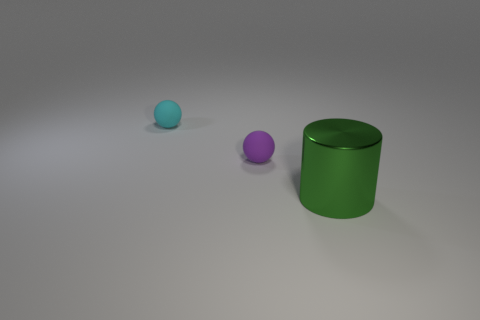What number of other metallic objects are the same shape as the small cyan object?
Offer a very short reply. 0. Do the large cylinder and the ball that is in front of the tiny cyan matte sphere have the same material?
Give a very brief answer. No. There is a cyan thing that is the same size as the purple rubber object; what is it made of?
Give a very brief answer. Rubber. Are there any purple rubber things that have the same size as the purple rubber ball?
Your answer should be very brief. No. There is another object that is the same size as the purple matte thing; what is its shape?
Your response must be concise. Sphere. How many other objects are the same color as the shiny object?
Make the answer very short. 0. Are there any green things that are on the left side of the rubber ball on the left side of the tiny rubber ball on the right side of the small cyan matte sphere?
Ensure brevity in your answer.  No. What number of other things are the same material as the small purple object?
Keep it short and to the point. 1. What number of big metallic cylinders are there?
Give a very brief answer. 1. What number of things are either gray metal cubes or things that are behind the metal cylinder?
Provide a succinct answer. 2. 